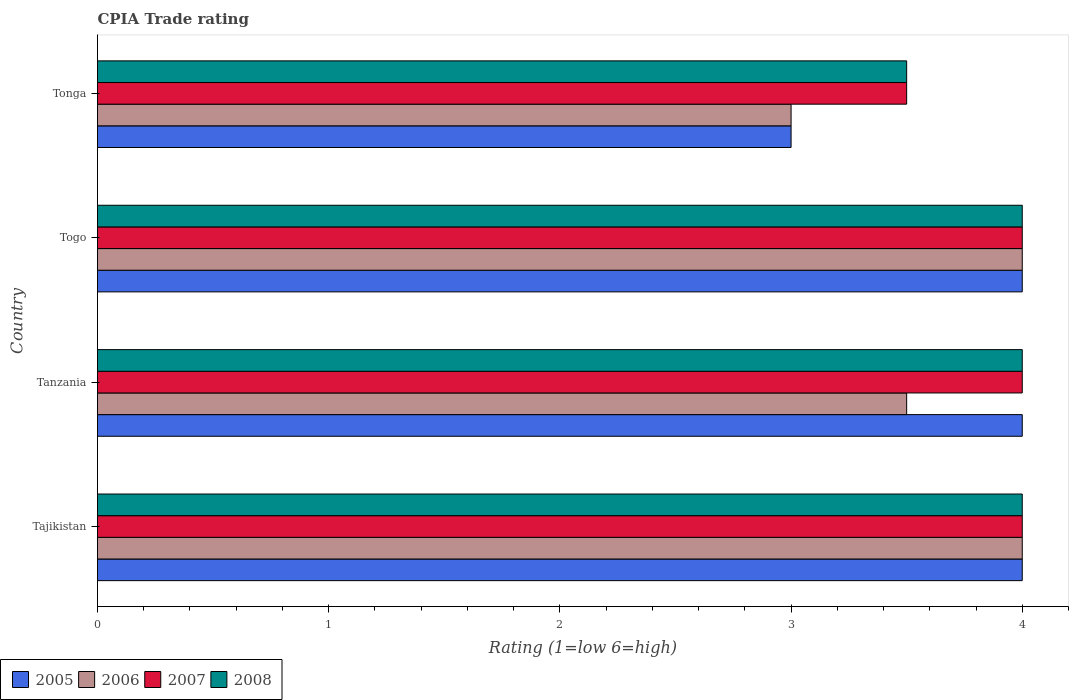How many bars are there on the 1st tick from the top?
Your answer should be very brief. 4. How many bars are there on the 4th tick from the bottom?
Your answer should be very brief. 4. What is the label of the 2nd group of bars from the top?
Keep it short and to the point. Togo. Across all countries, what is the maximum CPIA rating in 2007?
Your answer should be very brief. 4. Across all countries, what is the minimum CPIA rating in 2008?
Offer a terse response. 3.5. In which country was the CPIA rating in 2006 maximum?
Offer a terse response. Tajikistan. In which country was the CPIA rating in 2008 minimum?
Ensure brevity in your answer.  Tonga. What is the difference between the CPIA rating in 2005 in Tajikistan and that in Togo?
Offer a very short reply. 0. What is the average CPIA rating in 2005 per country?
Your answer should be compact. 3.75. What is the difference between the CPIA rating in 2007 and CPIA rating in 2005 in Tonga?
Your answer should be compact. 0.5. In how many countries, is the CPIA rating in 2007 greater than 3 ?
Offer a terse response. 4. Is the CPIA rating in 2007 in Tanzania less than that in Tonga?
Ensure brevity in your answer.  No. What is the difference between the highest and the second highest CPIA rating in 2008?
Ensure brevity in your answer.  0. What is the difference between the highest and the lowest CPIA rating in 2007?
Ensure brevity in your answer.  0.5. Is it the case that in every country, the sum of the CPIA rating in 2008 and CPIA rating in 2007 is greater than the sum of CPIA rating in 2005 and CPIA rating in 2006?
Give a very brief answer. No. What does the 1st bar from the top in Tajikistan represents?
Provide a succinct answer. 2008. What does the 3rd bar from the bottom in Togo represents?
Your answer should be compact. 2007. How many bars are there?
Provide a succinct answer. 16. Are all the bars in the graph horizontal?
Give a very brief answer. Yes. How many countries are there in the graph?
Offer a terse response. 4. What is the difference between two consecutive major ticks on the X-axis?
Ensure brevity in your answer.  1. Does the graph contain grids?
Offer a terse response. No. How many legend labels are there?
Give a very brief answer. 4. What is the title of the graph?
Keep it short and to the point. CPIA Trade rating. Does "1988" appear as one of the legend labels in the graph?
Offer a very short reply. No. What is the label or title of the X-axis?
Provide a short and direct response. Rating (1=low 6=high). What is the Rating (1=low 6=high) in 2005 in Tajikistan?
Provide a succinct answer. 4. What is the Rating (1=low 6=high) in 2007 in Tajikistan?
Your answer should be compact. 4. What is the Rating (1=low 6=high) in 2005 in Tanzania?
Offer a terse response. 4. What is the Rating (1=low 6=high) of 2006 in Tanzania?
Make the answer very short. 3.5. What is the Rating (1=low 6=high) in 2007 in Tanzania?
Offer a terse response. 4. What is the Rating (1=low 6=high) of 2005 in Togo?
Keep it short and to the point. 4. What is the Rating (1=low 6=high) in 2006 in Togo?
Keep it short and to the point. 4. What is the Rating (1=low 6=high) in 2007 in Togo?
Your response must be concise. 4. What is the Rating (1=low 6=high) of 2005 in Tonga?
Your answer should be very brief. 3. What is the Rating (1=low 6=high) of 2007 in Tonga?
Your answer should be compact. 3.5. What is the Rating (1=low 6=high) of 2008 in Tonga?
Provide a succinct answer. 3.5. Across all countries, what is the maximum Rating (1=low 6=high) of 2007?
Keep it short and to the point. 4. Across all countries, what is the maximum Rating (1=low 6=high) in 2008?
Offer a very short reply. 4. Across all countries, what is the minimum Rating (1=low 6=high) in 2007?
Your answer should be very brief. 3.5. What is the total Rating (1=low 6=high) of 2005 in the graph?
Give a very brief answer. 15. What is the total Rating (1=low 6=high) in 2006 in the graph?
Ensure brevity in your answer.  14.5. What is the total Rating (1=low 6=high) of 2007 in the graph?
Offer a very short reply. 15.5. What is the difference between the Rating (1=low 6=high) of 2006 in Tajikistan and that in Tanzania?
Your response must be concise. 0.5. What is the difference between the Rating (1=low 6=high) of 2007 in Tajikistan and that in Tanzania?
Give a very brief answer. 0. What is the difference between the Rating (1=low 6=high) of 2008 in Tajikistan and that in Tanzania?
Provide a short and direct response. 0. What is the difference between the Rating (1=low 6=high) in 2006 in Tajikistan and that in Togo?
Provide a short and direct response. 0. What is the difference between the Rating (1=low 6=high) of 2007 in Tajikistan and that in Togo?
Your answer should be very brief. 0. What is the difference between the Rating (1=low 6=high) of 2005 in Tajikistan and that in Tonga?
Your answer should be compact. 1. What is the difference between the Rating (1=low 6=high) of 2006 in Tajikistan and that in Tonga?
Offer a very short reply. 1. What is the difference between the Rating (1=low 6=high) of 2005 in Tanzania and that in Togo?
Provide a succinct answer. 0. What is the difference between the Rating (1=low 6=high) in 2006 in Tanzania and that in Togo?
Your answer should be compact. -0.5. What is the difference between the Rating (1=low 6=high) of 2008 in Tanzania and that in Togo?
Make the answer very short. 0. What is the difference between the Rating (1=low 6=high) of 2005 in Tanzania and that in Tonga?
Offer a very short reply. 1. What is the difference between the Rating (1=low 6=high) of 2008 in Tanzania and that in Tonga?
Provide a short and direct response. 0.5. What is the difference between the Rating (1=low 6=high) in 2005 in Togo and that in Tonga?
Your answer should be compact. 1. What is the difference between the Rating (1=low 6=high) of 2006 in Togo and that in Tonga?
Provide a succinct answer. 1. What is the difference between the Rating (1=low 6=high) in 2005 in Tajikistan and the Rating (1=low 6=high) in 2006 in Tanzania?
Provide a succinct answer. 0.5. What is the difference between the Rating (1=low 6=high) of 2005 in Tajikistan and the Rating (1=low 6=high) of 2008 in Tanzania?
Your answer should be compact. 0. What is the difference between the Rating (1=low 6=high) of 2006 in Tajikistan and the Rating (1=low 6=high) of 2007 in Tanzania?
Keep it short and to the point. 0. What is the difference between the Rating (1=low 6=high) of 2006 in Tajikistan and the Rating (1=low 6=high) of 2008 in Tanzania?
Offer a very short reply. 0. What is the difference between the Rating (1=low 6=high) of 2005 in Tajikistan and the Rating (1=low 6=high) of 2007 in Togo?
Offer a very short reply. 0. What is the difference between the Rating (1=low 6=high) of 2006 in Tajikistan and the Rating (1=low 6=high) of 2008 in Togo?
Provide a short and direct response. 0. What is the difference between the Rating (1=low 6=high) in 2005 in Tajikistan and the Rating (1=low 6=high) in 2006 in Tonga?
Offer a terse response. 1. What is the difference between the Rating (1=low 6=high) in 2005 in Tajikistan and the Rating (1=low 6=high) in 2007 in Tonga?
Offer a terse response. 0.5. What is the difference between the Rating (1=low 6=high) of 2005 in Tajikistan and the Rating (1=low 6=high) of 2008 in Tonga?
Provide a short and direct response. 0.5. What is the difference between the Rating (1=low 6=high) of 2006 in Tajikistan and the Rating (1=low 6=high) of 2007 in Tonga?
Make the answer very short. 0.5. What is the difference between the Rating (1=low 6=high) of 2006 in Tajikistan and the Rating (1=low 6=high) of 2008 in Tonga?
Keep it short and to the point. 0.5. What is the difference between the Rating (1=low 6=high) in 2007 in Tajikistan and the Rating (1=low 6=high) in 2008 in Tonga?
Your answer should be compact. 0.5. What is the difference between the Rating (1=low 6=high) of 2006 in Tanzania and the Rating (1=low 6=high) of 2007 in Togo?
Your answer should be compact. -0.5. What is the difference between the Rating (1=low 6=high) in 2006 in Tanzania and the Rating (1=low 6=high) in 2008 in Tonga?
Make the answer very short. 0. What is the difference between the Rating (1=low 6=high) of 2005 in Togo and the Rating (1=low 6=high) of 2008 in Tonga?
Offer a very short reply. 0.5. What is the difference between the Rating (1=low 6=high) in 2006 in Togo and the Rating (1=low 6=high) in 2007 in Tonga?
Your answer should be very brief. 0.5. What is the difference between the Rating (1=low 6=high) of 2007 in Togo and the Rating (1=low 6=high) of 2008 in Tonga?
Ensure brevity in your answer.  0.5. What is the average Rating (1=low 6=high) in 2005 per country?
Ensure brevity in your answer.  3.75. What is the average Rating (1=low 6=high) of 2006 per country?
Ensure brevity in your answer.  3.62. What is the average Rating (1=low 6=high) in 2007 per country?
Offer a terse response. 3.88. What is the average Rating (1=low 6=high) of 2008 per country?
Keep it short and to the point. 3.88. What is the difference between the Rating (1=low 6=high) of 2005 and Rating (1=low 6=high) of 2006 in Tajikistan?
Offer a terse response. 0. What is the difference between the Rating (1=low 6=high) in 2006 and Rating (1=low 6=high) in 2007 in Tajikistan?
Your answer should be very brief. 0. What is the difference between the Rating (1=low 6=high) in 2007 and Rating (1=low 6=high) in 2008 in Tajikistan?
Provide a succinct answer. 0. What is the difference between the Rating (1=low 6=high) of 2005 and Rating (1=low 6=high) of 2006 in Tanzania?
Offer a terse response. 0.5. What is the difference between the Rating (1=low 6=high) in 2006 and Rating (1=low 6=high) in 2008 in Tanzania?
Give a very brief answer. -0.5. What is the difference between the Rating (1=low 6=high) of 2007 and Rating (1=low 6=high) of 2008 in Tanzania?
Provide a succinct answer. 0. What is the difference between the Rating (1=low 6=high) of 2005 and Rating (1=low 6=high) of 2008 in Togo?
Your response must be concise. 0. What is the difference between the Rating (1=low 6=high) of 2006 and Rating (1=low 6=high) of 2007 in Togo?
Offer a terse response. 0. What is the difference between the Rating (1=low 6=high) in 2005 and Rating (1=low 6=high) in 2006 in Tonga?
Your answer should be compact. 0. What is the difference between the Rating (1=low 6=high) of 2005 and Rating (1=low 6=high) of 2007 in Tonga?
Provide a succinct answer. -0.5. What is the difference between the Rating (1=low 6=high) of 2006 and Rating (1=low 6=high) of 2007 in Tonga?
Provide a succinct answer. -0.5. What is the difference between the Rating (1=low 6=high) in 2007 and Rating (1=low 6=high) in 2008 in Tonga?
Give a very brief answer. 0. What is the ratio of the Rating (1=low 6=high) in 2005 in Tajikistan to that in Tanzania?
Your answer should be compact. 1. What is the ratio of the Rating (1=low 6=high) in 2007 in Tajikistan to that in Tanzania?
Provide a succinct answer. 1. What is the ratio of the Rating (1=low 6=high) in 2005 in Tajikistan to that in Togo?
Your response must be concise. 1. What is the ratio of the Rating (1=low 6=high) of 2006 in Tajikistan to that in Togo?
Your answer should be compact. 1. What is the ratio of the Rating (1=low 6=high) in 2007 in Tajikistan to that in Togo?
Give a very brief answer. 1. What is the ratio of the Rating (1=low 6=high) in 2006 in Tajikistan to that in Tonga?
Your answer should be compact. 1.33. What is the ratio of the Rating (1=low 6=high) of 2006 in Tanzania to that in Togo?
Keep it short and to the point. 0.88. What is the ratio of the Rating (1=low 6=high) of 2007 in Tanzania to that in Togo?
Your answer should be very brief. 1. What is the ratio of the Rating (1=low 6=high) of 2008 in Tanzania to that in Togo?
Offer a very short reply. 1. What is the ratio of the Rating (1=low 6=high) in 2005 in Togo to that in Tonga?
Keep it short and to the point. 1.33. What is the ratio of the Rating (1=low 6=high) in 2006 in Togo to that in Tonga?
Keep it short and to the point. 1.33. What is the ratio of the Rating (1=low 6=high) in 2007 in Togo to that in Tonga?
Ensure brevity in your answer.  1.14. What is the ratio of the Rating (1=low 6=high) in 2008 in Togo to that in Tonga?
Your response must be concise. 1.14. What is the difference between the highest and the second highest Rating (1=low 6=high) of 2006?
Offer a very short reply. 0. 